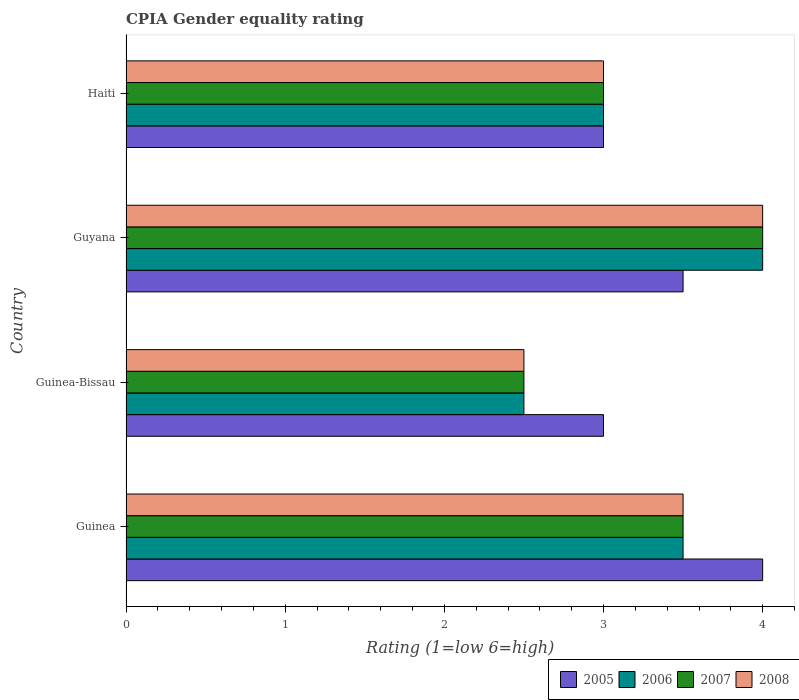How many different coloured bars are there?
Make the answer very short. 4. How many groups of bars are there?
Your answer should be compact. 4. Are the number of bars on each tick of the Y-axis equal?
Offer a terse response. Yes. How many bars are there on the 2nd tick from the top?
Your answer should be very brief. 4. How many bars are there on the 2nd tick from the bottom?
Give a very brief answer. 4. What is the label of the 1st group of bars from the top?
Provide a succinct answer. Haiti. What is the CPIA rating in 2005 in Guyana?
Make the answer very short. 3.5. In which country was the CPIA rating in 2008 maximum?
Offer a very short reply. Guyana. In which country was the CPIA rating in 2007 minimum?
Offer a very short reply. Guinea-Bissau. What is the total CPIA rating in 2006 in the graph?
Your answer should be compact. 13. What is the difference between the CPIA rating in 2006 in Guinea and the CPIA rating in 2008 in Guinea-Bissau?
Offer a terse response. 1. In how many countries, is the CPIA rating in 2007 greater than 0.2 ?
Your response must be concise. 4. What is the ratio of the CPIA rating in 2007 in Guinea to that in Guyana?
Keep it short and to the point. 0.88. Is the CPIA rating in 2006 in Guyana less than that in Haiti?
Your answer should be compact. No. Is the difference between the CPIA rating in 2008 in Guinea-Bissau and Guyana greater than the difference between the CPIA rating in 2005 in Guinea-Bissau and Guyana?
Offer a very short reply. No. In how many countries, is the CPIA rating in 2007 greater than the average CPIA rating in 2007 taken over all countries?
Keep it short and to the point. 2. What does the 3rd bar from the top in Haiti represents?
Make the answer very short. 2006. What does the 2nd bar from the bottom in Guinea represents?
Your answer should be very brief. 2006. Is it the case that in every country, the sum of the CPIA rating in 2006 and CPIA rating in 2005 is greater than the CPIA rating in 2008?
Ensure brevity in your answer.  Yes. What is the difference between two consecutive major ticks on the X-axis?
Offer a very short reply. 1. Does the graph contain grids?
Offer a terse response. No. Where does the legend appear in the graph?
Give a very brief answer. Bottom right. How are the legend labels stacked?
Offer a very short reply. Horizontal. What is the title of the graph?
Keep it short and to the point. CPIA Gender equality rating. Does "1997" appear as one of the legend labels in the graph?
Your answer should be compact. No. What is the Rating (1=low 6=high) of 2005 in Guinea?
Provide a succinct answer. 4. What is the Rating (1=low 6=high) in 2005 in Guinea-Bissau?
Your answer should be compact. 3. What is the Rating (1=low 6=high) of 2008 in Guinea-Bissau?
Keep it short and to the point. 2.5. What is the Rating (1=low 6=high) in 2005 in Guyana?
Give a very brief answer. 3.5. What is the Rating (1=low 6=high) in 2006 in Guyana?
Offer a very short reply. 4. What is the Rating (1=low 6=high) of 2008 in Guyana?
Your answer should be very brief. 4. What is the Rating (1=low 6=high) of 2006 in Haiti?
Your response must be concise. 3. What is the Rating (1=low 6=high) of 2008 in Haiti?
Your answer should be compact. 3. Across all countries, what is the maximum Rating (1=low 6=high) of 2006?
Keep it short and to the point. 4. Across all countries, what is the minimum Rating (1=low 6=high) of 2006?
Offer a terse response. 2.5. Across all countries, what is the minimum Rating (1=low 6=high) of 2008?
Provide a short and direct response. 2.5. What is the total Rating (1=low 6=high) in 2007 in the graph?
Give a very brief answer. 13. What is the difference between the Rating (1=low 6=high) in 2005 in Guinea and that in Guinea-Bissau?
Give a very brief answer. 1. What is the difference between the Rating (1=low 6=high) in 2006 in Guinea and that in Guinea-Bissau?
Your response must be concise. 1. What is the difference between the Rating (1=low 6=high) in 2007 in Guinea and that in Guinea-Bissau?
Your answer should be very brief. 1. What is the difference between the Rating (1=low 6=high) of 2005 in Guinea and that in Guyana?
Make the answer very short. 0.5. What is the difference between the Rating (1=low 6=high) in 2006 in Guinea and that in Guyana?
Your response must be concise. -0.5. What is the difference between the Rating (1=low 6=high) in 2007 in Guinea and that in Guyana?
Provide a succinct answer. -0.5. What is the difference between the Rating (1=low 6=high) in 2008 in Guinea and that in Guyana?
Make the answer very short. -0.5. What is the difference between the Rating (1=low 6=high) in 2008 in Guinea and that in Haiti?
Keep it short and to the point. 0.5. What is the difference between the Rating (1=low 6=high) in 2005 in Guinea-Bissau and that in Guyana?
Keep it short and to the point. -0.5. What is the difference between the Rating (1=low 6=high) of 2006 in Guinea-Bissau and that in Guyana?
Give a very brief answer. -1.5. What is the difference between the Rating (1=low 6=high) in 2007 in Guinea-Bissau and that in Guyana?
Provide a succinct answer. -1.5. What is the difference between the Rating (1=low 6=high) of 2008 in Guinea-Bissau and that in Guyana?
Keep it short and to the point. -1.5. What is the difference between the Rating (1=low 6=high) of 2006 in Guinea-Bissau and that in Haiti?
Keep it short and to the point. -0.5. What is the difference between the Rating (1=low 6=high) of 2005 in Guyana and that in Haiti?
Ensure brevity in your answer.  0.5. What is the difference between the Rating (1=low 6=high) in 2006 in Guyana and that in Haiti?
Your response must be concise. 1. What is the difference between the Rating (1=low 6=high) in 2007 in Guyana and that in Haiti?
Offer a terse response. 1. What is the difference between the Rating (1=low 6=high) of 2008 in Guyana and that in Haiti?
Offer a terse response. 1. What is the difference between the Rating (1=low 6=high) in 2005 in Guinea and the Rating (1=low 6=high) in 2007 in Guinea-Bissau?
Your response must be concise. 1.5. What is the difference between the Rating (1=low 6=high) in 2006 in Guinea and the Rating (1=low 6=high) in 2008 in Guinea-Bissau?
Ensure brevity in your answer.  1. What is the difference between the Rating (1=low 6=high) of 2005 in Guinea and the Rating (1=low 6=high) of 2007 in Guyana?
Give a very brief answer. 0. What is the difference between the Rating (1=low 6=high) of 2005 in Guinea and the Rating (1=low 6=high) of 2008 in Guyana?
Provide a short and direct response. 0. What is the difference between the Rating (1=low 6=high) of 2006 in Guinea and the Rating (1=low 6=high) of 2007 in Guyana?
Give a very brief answer. -0.5. What is the difference between the Rating (1=low 6=high) of 2006 in Guinea and the Rating (1=low 6=high) of 2008 in Guyana?
Keep it short and to the point. -0.5. What is the difference between the Rating (1=low 6=high) of 2007 in Guinea and the Rating (1=low 6=high) of 2008 in Guyana?
Offer a terse response. -0.5. What is the difference between the Rating (1=low 6=high) of 2005 in Guinea and the Rating (1=low 6=high) of 2007 in Haiti?
Make the answer very short. 1. What is the difference between the Rating (1=low 6=high) in 2005 in Guinea and the Rating (1=low 6=high) in 2008 in Haiti?
Your answer should be compact. 1. What is the difference between the Rating (1=low 6=high) of 2007 in Guinea and the Rating (1=low 6=high) of 2008 in Haiti?
Make the answer very short. 0.5. What is the difference between the Rating (1=low 6=high) in 2005 in Guinea-Bissau and the Rating (1=low 6=high) in 2007 in Guyana?
Keep it short and to the point. -1. What is the difference between the Rating (1=low 6=high) of 2005 in Guinea-Bissau and the Rating (1=low 6=high) of 2008 in Guyana?
Keep it short and to the point. -1. What is the difference between the Rating (1=low 6=high) of 2006 in Guinea-Bissau and the Rating (1=low 6=high) of 2008 in Guyana?
Your response must be concise. -1.5. What is the difference between the Rating (1=low 6=high) in 2007 in Guinea-Bissau and the Rating (1=low 6=high) in 2008 in Guyana?
Keep it short and to the point. -1.5. What is the difference between the Rating (1=low 6=high) in 2005 in Guinea-Bissau and the Rating (1=low 6=high) in 2007 in Haiti?
Offer a terse response. 0. What is the difference between the Rating (1=low 6=high) of 2005 in Guinea-Bissau and the Rating (1=low 6=high) of 2008 in Haiti?
Your answer should be compact. 0. What is the difference between the Rating (1=low 6=high) of 2006 in Guinea-Bissau and the Rating (1=low 6=high) of 2008 in Haiti?
Offer a terse response. -0.5. What is the difference between the Rating (1=low 6=high) in 2007 in Guinea-Bissau and the Rating (1=low 6=high) in 2008 in Haiti?
Offer a terse response. -0.5. What is the difference between the Rating (1=low 6=high) of 2005 in Guyana and the Rating (1=low 6=high) of 2006 in Haiti?
Offer a terse response. 0.5. What is the difference between the Rating (1=low 6=high) of 2006 in Guyana and the Rating (1=low 6=high) of 2008 in Haiti?
Give a very brief answer. 1. What is the difference between the Rating (1=low 6=high) of 2007 in Guyana and the Rating (1=low 6=high) of 2008 in Haiti?
Give a very brief answer. 1. What is the average Rating (1=low 6=high) of 2005 per country?
Give a very brief answer. 3.38. What is the average Rating (1=low 6=high) in 2006 per country?
Your answer should be compact. 3.25. What is the difference between the Rating (1=low 6=high) in 2005 and Rating (1=low 6=high) in 2006 in Guinea?
Offer a terse response. 0.5. What is the difference between the Rating (1=low 6=high) in 2005 and Rating (1=low 6=high) in 2008 in Guinea?
Make the answer very short. 0.5. What is the difference between the Rating (1=low 6=high) of 2007 and Rating (1=low 6=high) of 2008 in Guinea?
Keep it short and to the point. 0. What is the difference between the Rating (1=low 6=high) in 2005 and Rating (1=low 6=high) in 2008 in Guinea-Bissau?
Keep it short and to the point. 0.5. What is the difference between the Rating (1=low 6=high) of 2006 and Rating (1=low 6=high) of 2008 in Guinea-Bissau?
Offer a very short reply. 0. What is the difference between the Rating (1=low 6=high) of 2007 and Rating (1=low 6=high) of 2008 in Guinea-Bissau?
Your answer should be compact. 0. What is the difference between the Rating (1=low 6=high) of 2005 and Rating (1=low 6=high) of 2006 in Guyana?
Offer a terse response. -0.5. What is the difference between the Rating (1=low 6=high) in 2005 and Rating (1=low 6=high) in 2007 in Guyana?
Make the answer very short. -0.5. What is the difference between the Rating (1=low 6=high) in 2005 and Rating (1=low 6=high) in 2008 in Guyana?
Give a very brief answer. -0.5. What is the difference between the Rating (1=low 6=high) in 2006 and Rating (1=low 6=high) in 2008 in Guyana?
Your response must be concise. 0. What is the difference between the Rating (1=low 6=high) in 2005 and Rating (1=low 6=high) in 2006 in Haiti?
Provide a short and direct response. 0. What is the difference between the Rating (1=low 6=high) of 2005 and Rating (1=low 6=high) of 2007 in Haiti?
Your answer should be very brief. 0. What is the difference between the Rating (1=low 6=high) in 2006 and Rating (1=low 6=high) in 2007 in Haiti?
Offer a very short reply. 0. What is the ratio of the Rating (1=low 6=high) of 2006 in Guinea to that in Guinea-Bissau?
Offer a very short reply. 1.4. What is the ratio of the Rating (1=low 6=high) in 2007 in Guinea to that in Guinea-Bissau?
Keep it short and to the point. 1.4. What is the ratio of the Rating (1=low 6=high) of 2008 in Guinea to that in Guinea-Bissau?
Offer a terse response. 1.4. What is the ratio of the Rating (1=low 6=high) in 2005 in Guinea to that in Guyana?
Provide a short and direct response. 1.14. What is the ratio of the Rating (1=low 6=high) of 2006 in Guinea to that in Guyana?
Provide a succinct answer. 0.88. What is the ratio of the Rating (1=low 6=high) in 2007 in Guinea to that in Guyana?
Offer a very short reply. 0.88. What is the ratio of the Rating (1=low 6=high) in 2008 in Guinea to that in Guyana?
Your response must be concise. 0.88. What is the ratio of the Rating (1=low 6=high) in 2005 in Guinea to that in Haiti?
Make the answer very short. 1.33. What is the ratio of the Rating (1=low 6=high) of 2006 in Guinea to that in Haiti?
Provide a succinct answer. 1.17. What is the ratio of the Rating (1=low 6=high) of 2006 in Guinea-Bissau to that in Guyana?
Provide a succinct answer. 0.62. What is the ratio of the Rating (1=low 6=high) in 2008 in Guinea-Bissau to that in Guyana?
Provide a succinct answer. 0.62. What is the ratio of the Rating (1=low 6=high) in 2005 in Guinea-Bissau to that in Haiti?
Keep it short and to the point. 1. What is the ratio of the Rating (1=low 6=high) of 2008 in Guinea-Bissau to that in Haiti?
Make the answer very short. 0.83. What is the ratio of the Rating (1=low 6=high) in 2006 in Guyana to that in Haiti?
Ensure brevity in your answer.  1.33. What is the ratio of the Rating (1=low 6=high) of 2008 in Guyana to that in Haiti?
Give a very brief answer. 1.33. What is the difference between the highest and the second highest Rating (1=low 6=high) in 2006?
Provide a succinct answer. 0.5. What is the difference between the highest and the second highest Rating (1=low 6=high) in 2008?
Your response must be concise. 0.5. What is the difference between the highest and the lowest Rating (1=low 6=high) in 2006?
Give a very brief answer. 1.5. What is the difference between the highest and the lowest Rating (1=low 6=high) in 2008?
Offer a terse response. 1.5. 